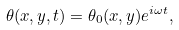Convert formula to latex. <formula><loc_0><loc_0><loc_500><loc_500>\theta ( x , y , t ) = \theta _ { 0 } ( x , y ) e ^ { i \omega t } ,</formula> 